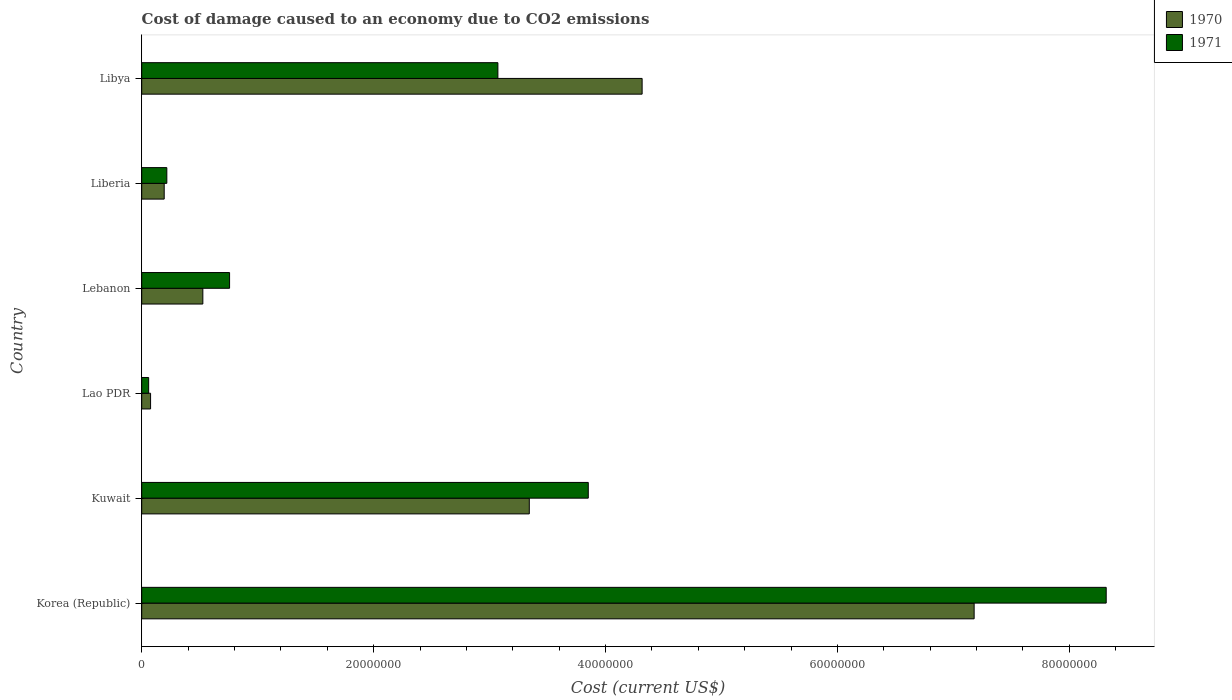Are the number of bars per tick equal to the number of legend labels?
Provide a short and direct response. Yes. Are the number of bars on each tick of the Y-axis equal?
Offer a very short reply. Yes. How many bars are there on the 5th tick from the bottom?
Provide a succinct answer. 2. What is the label of the 5th group of bars from the top?
Make the answer very short. Kuwait. What is the cost of damage caused due to CO2 emissisons in 1970 in Lebanon?
Your answer should be compact. 5.27e+06. Across all countries, what is the maximum cost of damage caused due to CO2 emissisons in 1971?
Offer a very short reply. 8.32e+07. Across all countries, what is the minimum cost of damage caused due to CO2 emissisons in 1970?
Your answer should be very brief. 7.64e+05. In which country was the cost of damage caused due to CO2 emissisons in 1970 maximum?
Keep it short and to the point. Korea (Republic). In which country was the cost of damage caused due to CO2 emissisons in 1970 minimum?
Provide a short and direct response. Lao PDR. What is the total cost of damage caused due to CO2 emissisons in 1971 in the graph?
Ensure brevity in your answer.  1.63e+08. What is the difference between the cost of damage caused due to CO2 emissisons in 1970 in Korea (Republic) and that in Lebanon?
Your answer should be compact. 6.65e+07. What is the difference between the cost of damage caused due to CO2 emissisons in 1970 in Lebanon and the cost of damage caused due to CO2 emissisons in 1971 in Liberia?
Keep it short and to the point. 3.11e+06. What is the average cost of damage caused due to CO2 emissisons in 1970 per country?
Provide a short and direct response. 2.61e+07. What is the difference between the cost of damage caused due to CO2 emissisons in 1971 and cost of damage caused due to CO2 emissisons in 1970 in Lao PDR?
Your answer should be compact. -1.65e+05. What is the ratio of the cost of damage caused due to CO2 emissisons in 1970 in Liberia to that in Libya?
Provide a succinct answer. 0.04. Is the cost of damage caused due to CO2 emissisons in 1971 in Kuwait less than that in Lao PDR?
Give a very brief answer. No. What is the difference between the highest and the second highest cost of damage caused due to CO2 emissisons in 1970?
Give a very brief answer. 2.86e+07. What is the difference between the highest and the lowest cost of damage caused due to CO2 emissisons in 1971?
Your answer should be compact. 8.26e+07. Is the sum of the cost of damage caused due to CO2 emissisons in 1970 in Kuwait and Lao PDR greater than the maximum cost of damage caused due to CO2 emissisons in 1971 across all countries?
Keep it short and to the point. No. What does the 1st bar from the top in Lebanon represents?
Offer a very short reply. 1971. What does the 1st bar from the bottom in Lao PDR represents?
Your response must be concise. 1970. Are all the bars in the graph horizontal?
Provide a short and direct response. Yes. How many countries are there in the graph?
Your answer should be compact. 6. What is the difference between two consecutive major ticks on the X-axis?
Your response must be concise. 2.00e+07. Does the graph contain any zero values?
Your answer should be very brief. No. What is the title of the graph?
Provide a short and direct response. Cost of damage caused to an economy due to CO2 emissions. What is the label or title of the X-axis?
Your answer should be very brief. Cost (current US$). What is the Cost (current US$) of 1970 in Korea (Republic)?
Provide a short and direct response. 7.18e+07. What is the Cost (current US$) in 1971 in Korea (Republic)?
Make the answer very short. 8.32e+07. What is the Cost (current US$) in 1970 in Kuwait?
Your response must be concise. 3.34e+07. What is the Cost (current US$) in 1971 in Kuwait?
Offer a very short reply. 3.85e+07. What is the Cost (current US$) in 1970 in Lao PDR?
Provide a succinct answer. 7.64e+05. What is the Cost (current US$) in 1971 in Lao PDR?
Offer a terse response. 5.98e+05. What is the Cost (current US$) of 1970 in Lebanon?
Offer a very short reply. 5.27e+06. What is the Cost (current US$) in 1971 in Lebanon?
Your answer should be compact. 7.58e+06. What is the Cost (current US$) in 1970 in Liberia?
Give a very brief answer. 1.94e+06. What is the Cost (current US$) in 1971 in Liberia?
Your response must be concise. 2.16e+06. What is the Cost (current US$) of 1970 in Libya?
Your response must be concise. 4.32e+07. What is the Cost (current US$) of 1971 in Libya?
Make the answer very short. 3.07e+07. Across all countries, what is the maximum Cost (current US$) in 1970?
Ensure brevity in your answer.  7.18e+07. Across all countries, what is the maximum Cost (current US$) of 1971?
Your answer should be very brief. 8.32e+07. Across all countries, what is the minimum Cost (current US$) in 1970?
Your response must be concise. 7.64e+05. Across all countries, what is the minimum Cost (current US$) in 1971?
Your answer should be very brief. 5.98e+05. What is the total Cost (current US$) in 1970 in the graph?
Provide a succinct answer. 1.56e+08. What is the total Cost (current US$) in 1971 in the graph?
Keep it short and to the point. 1.63e+08. What is the difference between the Cost (current US$) of 1970 in Korea (Republic) and that in Kuwait?
Your answer should be very brief. 3.84e+07. What is the difference between the Cost (current US$) of 1971 in Korea (Republic) and that in Kuwait?
Your answer should be very brief. 4.47e+07. What is the difference between the Cost (current US$) in 1970 in Korea (Republic) and that in Lao PDR?
Your response must be concise. 7.10e+07. What is the difference between the Cost (current US$) of 1971 in Korea (Republic) and that in Lao PDR?
Your response must be concise. 8.26e+07. What is the difference between the Cost (current US$) in 1970 in Korea (Republic) and that in Lebanon?
Offer a terse response. 6.65e+07. What is the difference between the Cost (current US$) of 1971 in Korea (Republic) and that in Lebanon?
Give a very brief answer. 7.56e+07. What is the difference between the Cost (current US$) of 1970 in Korea (Republic) and that in Liberia?
Give a very brief answer. 6.99e+07. What is the difference between the Cost (current US$) in 1971 in Korea (Republic) and that in Liberia?
Your response must be concise. 8.10e+07. What is the difference between the Cost (current US$) in 1970 in Korea (Republic) and that in Libya?
Keep it short and to the point. 2.86e+07. What is the difference between the Cost (current US$) in 1971 in Korea (Republic) and that in Libya?
Keep it short and to the point. 5.25e+07. What is the difference between the Cost (current US$) of 1970 in Kuwait and that in Lao PDR?
Your answer should be very brief. 3.27e+07. What is the difference between the Cost (current US$) of 1971 in Kuwait and that in Lao PDR?
Your response must be concise. 3.79e+07. What is the difference between the Cost (current US$) of 1970 in Kuwait and that in Lebanon?
Provide a succinct answer. 2.82e+07. What is the difference between the Cost (current US$) of 1971 in Kuwait and that in Lebanon?
Ensure brevity in your answer.  3.09e+07. What is the difference between the Cost (current US$) of 1970 in Kuwait and that in Liberia?
Your response must be concise. 3.15e+07. What is the difference between the Cost (current US$) of 1971 in Kuwait and that in Liberia?
Make the answer very short. 3.63e+07. What is the difference between the Cost (current US$) of 1970 in Kuwait and that in Libya?
Provide a succinct answer. -9.73e+06. What is the difference between the Cost (current US$) in 1971 in Kuwait and that in Libya?
Provide a short and direct response. 7.80e+06. What is the difference between the Cost (current US$) in 1970 in Lao PDR and that in Lebanon?
Provide a succinct answer. -4.51e+06. What is the difference between the Cost (current US$) in 1971 in Lao PDR and that in Lebanon?
Keep it short and to the point. -6.98e+06. What is the difference between the Cost (current US$) of 1970 in Lao PDR and that in Liberia?
Provide a succinct answer. -1.17e+06. What is the difference between the Cost (current US$) in 1971 in Lao PDR and that in Liberia?
Your response must be concise. -1.57e+06. What is the difference between the Cost (current US$) in 1970 in Lao PDR and that in Libya?
Keep it short and to the point. -4.24e+07. What is the difference between the Cost (current US$) in 1971 in Lao PDR and that in Libya?
Your answer should be compact. -3.01e+07. What is the difference between the Cost (current US$) in 1970 in Lebanon and that in Liberia?
Offer a very short reply. 3.33e+06. What is the difference between the Cost (current US$) in 1971 in Lebanon and that in Liberia?
Your response must be concise. 5.41e+06. What is the difference between the Cost (current US$) in 1970 in Lebanon and that in Libya?
Provide a succinct answer. -3.79e+07. What is the difference between the Cost (current US$) in 1971 in Lebanon and that in Libya?
Ensure brevity in your answer.  -2.31e+07. What is the difference between the Cost (current US$) in 1970 in Liberia and that in Libya?
Offer a terse response. -4.12e+07. What is the difference between the Cost (current US$) in 1971 in Liberia and that in Libya?
Offer a very short reply. -2.86e+07. What is the difference between the Cost (current US$) of 1970 in Korea (Republic) and the Cost (current US$) of 1971 in Kuwait?
Offer a terse response. 3.33e+07. What is the difference between the Cost (current US$) in 1970 in Korea (Republic) and the Cost (current US$) in 1971 in Lao PDR?
Make the answer very short. 7.12e+07. What is the difference between the Cost (current US$) in 1970 in Korea (Republic) and the Cost (current US$) in 1971 in Lebanon?
Offer a very short reply. 6.42e+07. What is the difference between the Cost (current US$) of 1970 in Korea (Republic) and the Cost (current US$) of 1971 in Liberia?
Offer a terse response. 6.96e+07. What is the difference between the Cost (current US$) of 1970 in Korea (Republic) and the Cost (current US$) of 1971 in Libya?
Provide a short and direct response. 4.11e+07. What is the difference between the Cost (current US$) of 1970 in Kuwait and the Cost (current US$) of 1971 in Lao PDR?
Provide a succinct answer. 3.28e+07. What is the difference between the Cost (current US$) in 1970 in Kuwait and the Cost (current US$) in 1971 in Lebanon?
Give a very brief answer. 2.58e+07. What is the difference between the Cost (current US$) in 1970 in Kuwait and the Cost (current US$) in 1971 in Liberia?
Give a very brief answer. 3.13e+07. What is the difference between the Cost (current US$) in 1970 in Kuwait and the Cost (current US$) in 1971 in Libya?
Offer a very short reply. 2.71e+06. What is the difference between the Cost (current US$) in 1970 in Lao PDR and the Cost (current US$) in 1971 in Lebanon?
Offer a very short reply. -6.81e+06. What is the difference between the Cost (current US$) of 1970 in Lao PDR and the Cost (current US$) of 1971 in Liberia?
Make the answer very short. -1.40e+06. What is the difference between the Cost (current US$) in 1970 in Lao PDR and the Cost (current US$) in 1971 in Libya?
Ensure brevity in your answer.  -3.00e+07. What is the difference between the Cost (current US$) in 1970 in Lebanon and the Cost (current US$) in 1971 in Liberia?
Offer a terse response. 3.11e+06. What is the difference between the Cost (current US$) of 1970 in Lebanon and the Cost (current US$) of 1971 in Libya?
Your response must be concise. -2.54e+07. What is the difference between the Cost (current US$) of 1970 in Liberia and the Cost (current US$) of 1971 in Libya?
Your answer should be compact. -2.88e+07. What is the average Cost (current US$) of 1970 per country?
Your answer should be compact. 2.61e+07. What is the average Cost (current US$) of 1971 per country?
Give a very brief answer. 2.71e+07. What is the difference between the Cost (current US$) of 1970 and Cost (current US$) of 1971 in Korea (Republic)?
Your response must be concise. -1.14e+07. What is the difference between the Cost (current US$) of 1970 and Cost (current US$) of 1971 in Kuwait?
Your response must be concise. -5.09e+06. What is the difference between the Cost (current US$) in 1970 and Cost (current US$) in 1971 in Lao PDR?
Give a very brief answer. 1.65e+05. What is the difference between the Cost (current US$) in 1970 and Cost (current US$) in 1971 in Lebanon?
Your response must be concise. -2.30e+06. What is the difference between the Cost (current US$) in 1970 and Cost (current US$) in 1971 in Liberia?
Give a very brief answer. -2.26e+05. What is the difference between the Cost (current US$) of 1970 and Cost (current US$) of 1971 in Libya?
Give a very brief answer. 1.24e+07. What is the ratio of the Cost (current US$) in 1970 in Korea (Republic) to that in Kuwait?
Provide a short and direct response. 2.15. What is the ratio of the Cost (current US$) in 1971 in Korea (Republic) to that in Kuwait?
Provide a short and direct response. 2.16. What is the ratio of the Cost (current US$) in 1970 in Korea (Republic) to that in Lao PDR?
Give a very brief answer. 94.02. What is the ratio of the Cost (current US$) in 1971 in Korea (Republic) to that in Lao PDR?
Your answer should be compact. 139. What is the ratio of the Cost (current US$) of 1970 in Korea (Republic) to that in Lebanon?
Give a very brief answer. 13.62. What is the ratio of the Cost (current US$) of 1971 in Korea (Republic) to that in Lebanon?
Provide a succinct answer. 10.98. What is the ratio of the Cost (current US$) of 1970 in Korea (Republic) to that in Liberia?
Your response must be concise. 37.04. What is the ratio of the Cost (current US$) of 1971 in Korea (Republic) to that in Liberia?
Offer a very short reply. 38.43. What is the ratio of the Cost (current US$) of 1970 in Korea (Republic) to that in Libya?
Provide a succinct answer. 1.66. What is the ratio of the Cost (current US$) of 1971 in Korea (Republic) to that in Libya?
Provide a succinct answer. 2.71. What is the ratio of the Cost (current US$) in 1970 in Kuwait to that in Lao PDR?
Your answer should be compact. 43.78. What is the ratio of the Cost (current US$) in 1971 in Kuwait to that in Lao PDR?
Keep it short and to the point. 64.36. What is the ratio of the Cost (current US$) of 1970 in Kuwait to that in Lebanon?
Your response must be concise. 6.34. What is the ratio of the Cost (current US$) of 1971 in Kuwait to that in Lebanon?
Give a very brief answer. 5.08. What is the ratio of the Cost (current US$) in 1970 in Kuwait to that in Liberia?
Provide a succinct answer. 17.24. What is the ratio of the Cost (current US$) of 1971 in Kuwait to that in Liberia?
Your response must be concise. 17.79. What is the ratio of the Cost (current US$) in 1970 in Kuwait to that in Libya?
Your answer should be compact. 0.77. What is the ratio of the Cost (current US$) of 1971 in Kuwait to that in Libya?
Offer a very short reply. 1.25. What is the ratio of the Cost (current US$) of 1970 in Lao PDR to that in Lebanon?
Ensure brevity in your answer.  0.14. What is the ratio of the Cost (current US$) in 1971 in Lao PDR to that in Lebanon?
Ensure brevity in your answer.  0.08. What is the ratio of the Cost (current US$) in 1970 in Lao PDR to that in Liberia?
Provide a succinct answer. 0.39. What is the ratio of the Cost (current US$) in 1971 in Lao PDR to that in Liberia?
Keep it short and to the point. 0.28. What is the ratio of the Cost (current US$) in 1970 in Lao PDR to that in Libya?
Ensure brevity in your answer.  0.02. What is the ratio of the Cost (current US$) of 1971 in Lao PDR to that in Libya?
Offer a terse response. 0.02. What is the ratio of the Cost (current US$) of 1970 in Lebanon to that in Liberia?
Offer a terse response. 2.72. What is the ratio of the Cost (current US$) of 1970 in Lebanon to that in Libya?
Offer a terse response. 0.12. What is the ratio of the Cost (current US$) of 1971 in Lebanon to that in Libya?
Make the answer very short. 0.25. What is the ratio of the Cost (current US$) in 1970 in Liberia to that in Libya?
Make the answer very short. 0.04. What is the ratio of the Cost (current US$) of 1971 in Liberia to that in Libya?
Offer a very short reply. 0.07. What is the difference between the highest and the second highest Cost (current US$) of 1970?
Give a very brief answer. 2.86e+07. What is the difference between the highest and the second highest Cost (current US$) of 1971?
Give a very brief answer. 4.47e+07. What is the difference between the highest and the lowest Cost (current US$) in 1970?
Keep it short and to the point. 7.10e+07. What is the difference between the highest and the lowest Cost (current US$) in 1971?
Provide a short and direct response. 8.26e+07. 